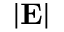<formula> <loc_0><loc_0><loc_500><loc_500>| E |</formula> 